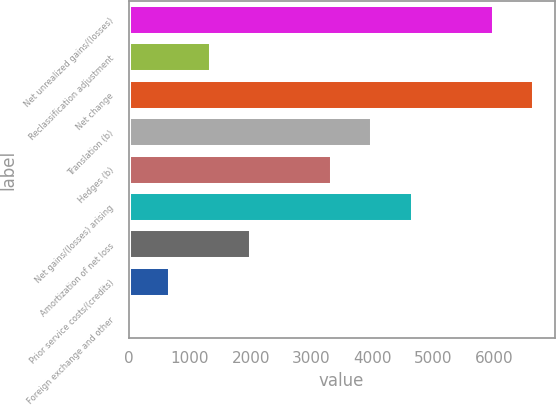Convert chart. <chart><loc_0><loc_0><loc_500><loc_500><bar_chart><fcel>Net unrealized gains/(losses)<fcel>Reclassification adjustment<fcel>Net change<fcel>Translation (b)<fcel>Hedges (b)<fcel>Net gains/(losses) arising<fcel>Amortization of net loss<fcel>Prior service costs/(credits)<fcel>Foreign exchange and other<nl><fcel>5990<fcel>1342<fcel>6654<fcel>3998<fcel>3334<fcel>4662<fcel>2006<fcel>678<fcel>14<nl></chart> 